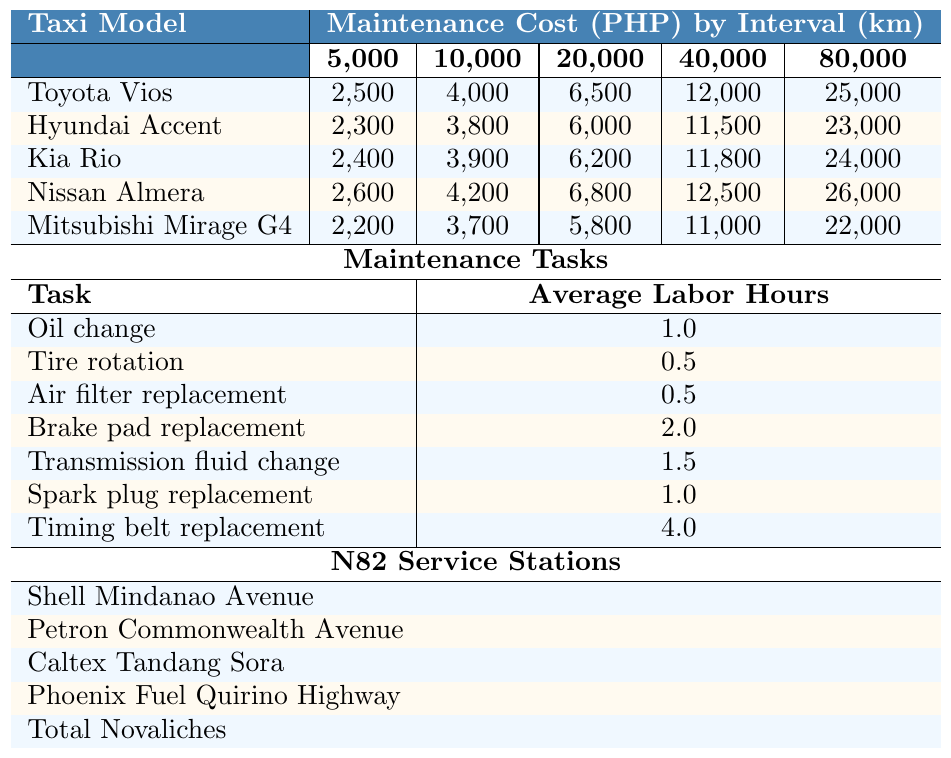What is the maintenance cost for a Toyota Vios at 20,000 km? The table shows that the maintenance cost for a Toyota Vios at 20,000 km is 6,500 PHP.
Answer: 6,500 PHP Which taxi model has the highest maintenance cost at 80,000 km? By comparing the last column of the table for all taxi models, Nissan Almera has the highest maintenance cost at 80,000 km, which is 26,000 PHP.
Answer: Nissan Almera What is the average maintenance cost for the Hyundai Accent at intervals of 10,000 km and 20,000 km combined? The maintenance costs for Hyundai Accent at 10,000 km is 3,800 PHP and at 20,000 km is 6,000 PHP. The total combined cost is 3,800 + 6,000 = 9,800 PHP, and there are 2 intervals, so the average is 9,800 / 2 = 4,900 PHP.
Answer: 4,900 PHP Is the maintenance cost for the Mitsubishi Mirage G4 at 40,000 km less than the cost for the Kia Rio at the same interval? The cost for Mitsubishi Mirage G4 at 40,000 km is 11,000 PHP, while the cost for Kia Rio at 40,000 km is 11,800 PHP. Since 11,000 is less than 11,800, the statement is true.
Answer: Yes What is the total maintenance cost for a Toyota Vios from 5,000 km to 80,000 km? The maintenance costs for Toyota Vios are: 2,500 (5,000) + 4,000 (10,000) + 6,500 (20,000) + 12,000 (40,000) + 25,000 (80,000) = 49,000 PHP. Therefore, the total cost is 49,000 PHP.
Answer: 49,000 PHP Which taxi model requires the highest number of average labor hours for timing belt replacement? The table shows that the average labor hours for timing belt replacement is 4 hours for all models. Therefore, no model has a higher average.
Answer: All models have the same hours What maintenance task for any taxi model takes the least average labor hours? By examining the average labor hours, tire rotation and air filter replacement both take the least time at 0.5 hours, which is lower than others.
Answer: Tire rotation and air filter replacement For Nissan Almera, what is the cost difference between the maintenance at 10,000 km and 40,000 km? The maintenance cost for Nissan Almera at 10,000 km is 4,200 PHP and at 40,000 km is 12,500 PHP. The cost difference is 12,500 - 4,200 = 8,300 PHP.
Answer: 8,300 PHP Is the maintenance cost for the Kia Rio at 5,000 km higher than the cost for the Mitsubishi Mirage G4 at the same interval? The cost for Kia Rio at 5,000 km is 2,400 PHP, while for Mitsubishi Mirage G4 it is 2,200 PHP. Since 2,400 is greater than 2,200, the statement is true.
Answer: Yes How much would it cost to maintain a Toyota Vios from 5,000 km to 10,000 km compared to a Nissan Almera at the same intervals? The maintenance cost for Toyota Vios from 5,000 km to 10,000 km is 2,500 + 4,000 = 6,500 PHP. For Nissan Almera, it is 2,600 + 4,200 = 6,800 PHP. The difference is 6,800 - 6,500 = 300 PHP.
Answer: 300 PHP 